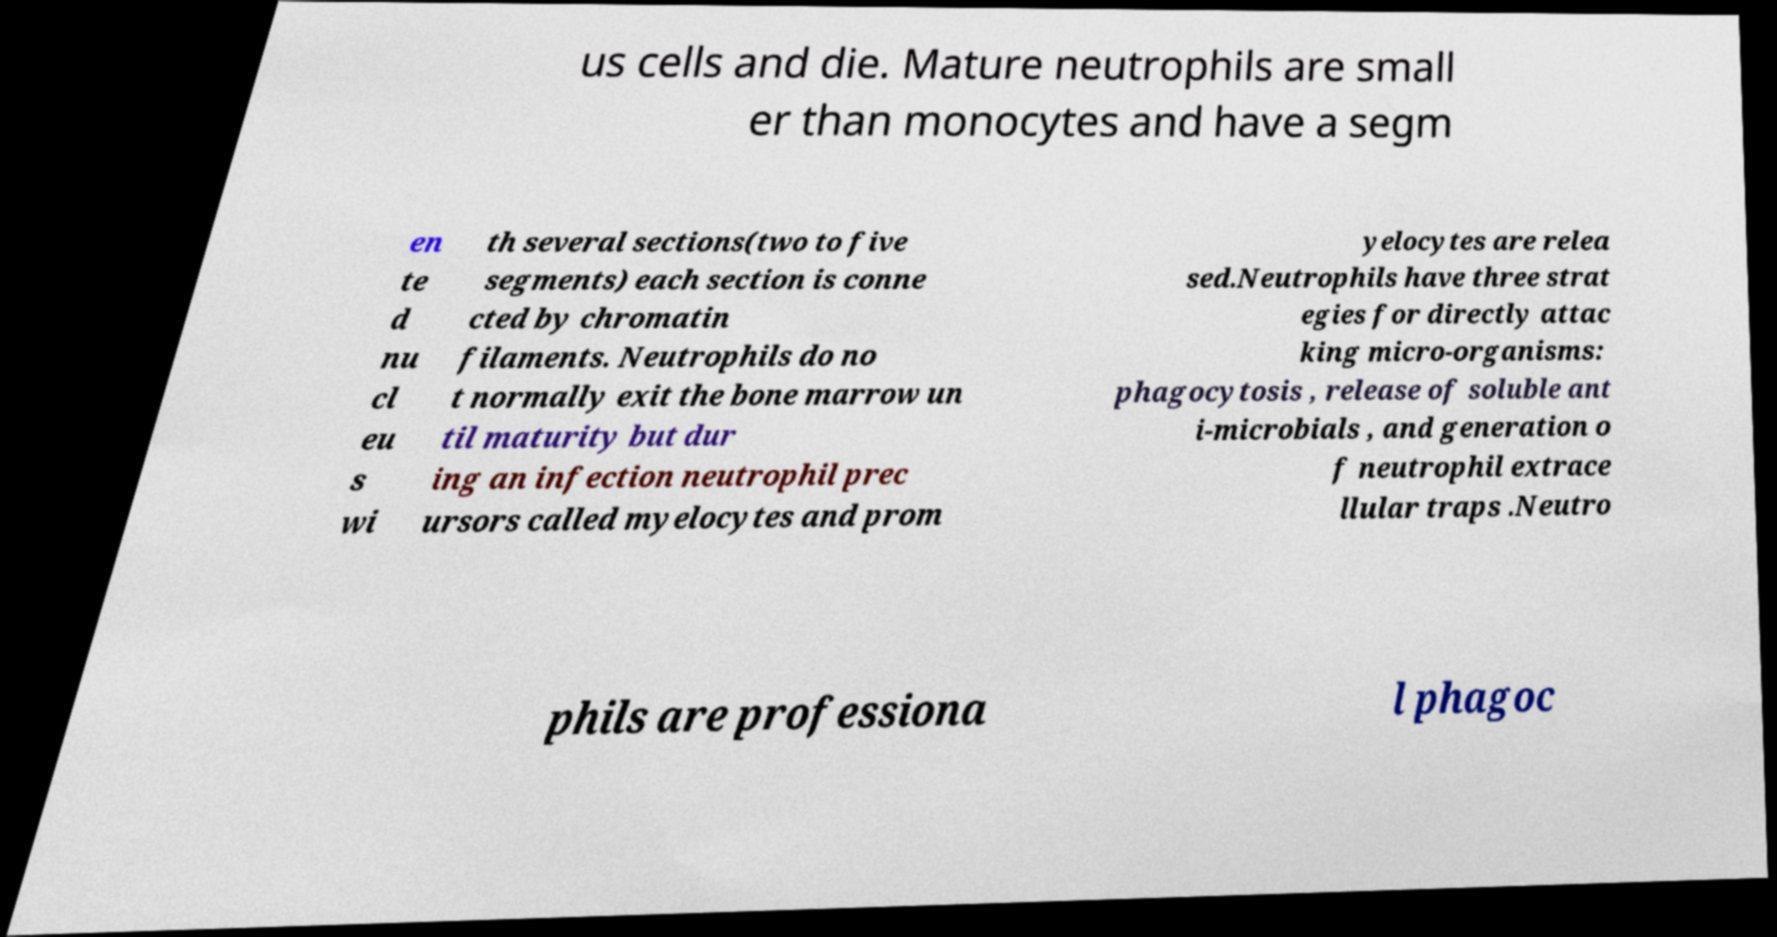Please read and relay the text visible in this image. What does it say? us cells and die. Mature neutrophils are small er than monocytes and have a segm en te d nu cl eu s wi th several sections(two to five segments) each section is conne cted by chromatin filaments. Neutrophils do no t normally exit the bone marrow un til maturity but dur ing an infection neutrophil prec ursors called myelocytes and prom yelocytes are relea sed.Neutrophils have three strat egies for directly attac king micro-organisms: phagocytosis , release of soluble ant i-microbials , and generation o f neutrophil extrace llular traps .Neutro phils are professiona l phagoc 